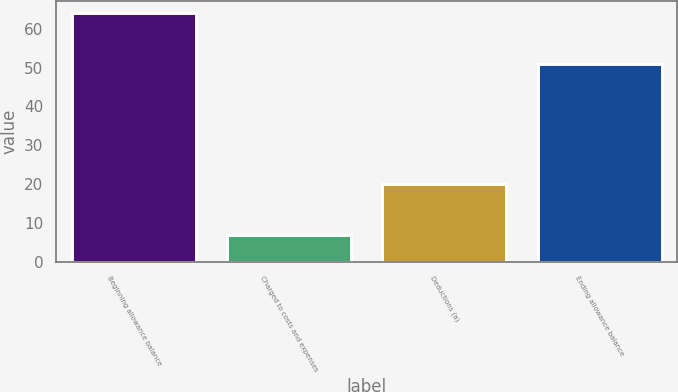Convert chart to OTSL. <chart><loc_0><loc_0><loc_500><loc_500><bar_chart><fcel>Beginning allowance balance<fcel>Charged to costs and expenses<fcel>Deductions (a)<fcel>Ending allowance balance<nl><fcel>64<fcel>7<fcel>20<fcel>51<nl></chart> 